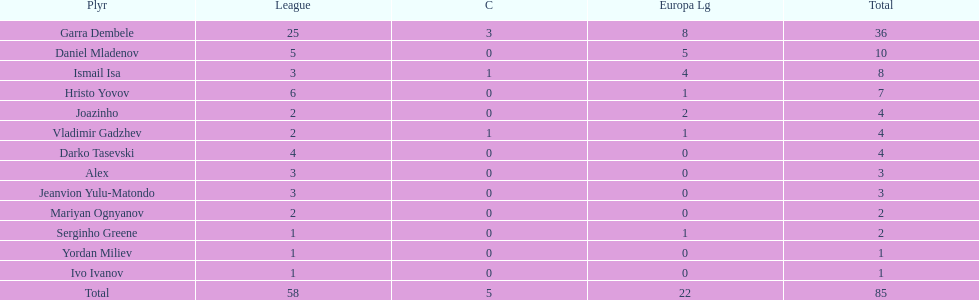Which players have at least 4 in the europa league? Garra Dembele, Daniel Mladenov, Ismail Isa. 